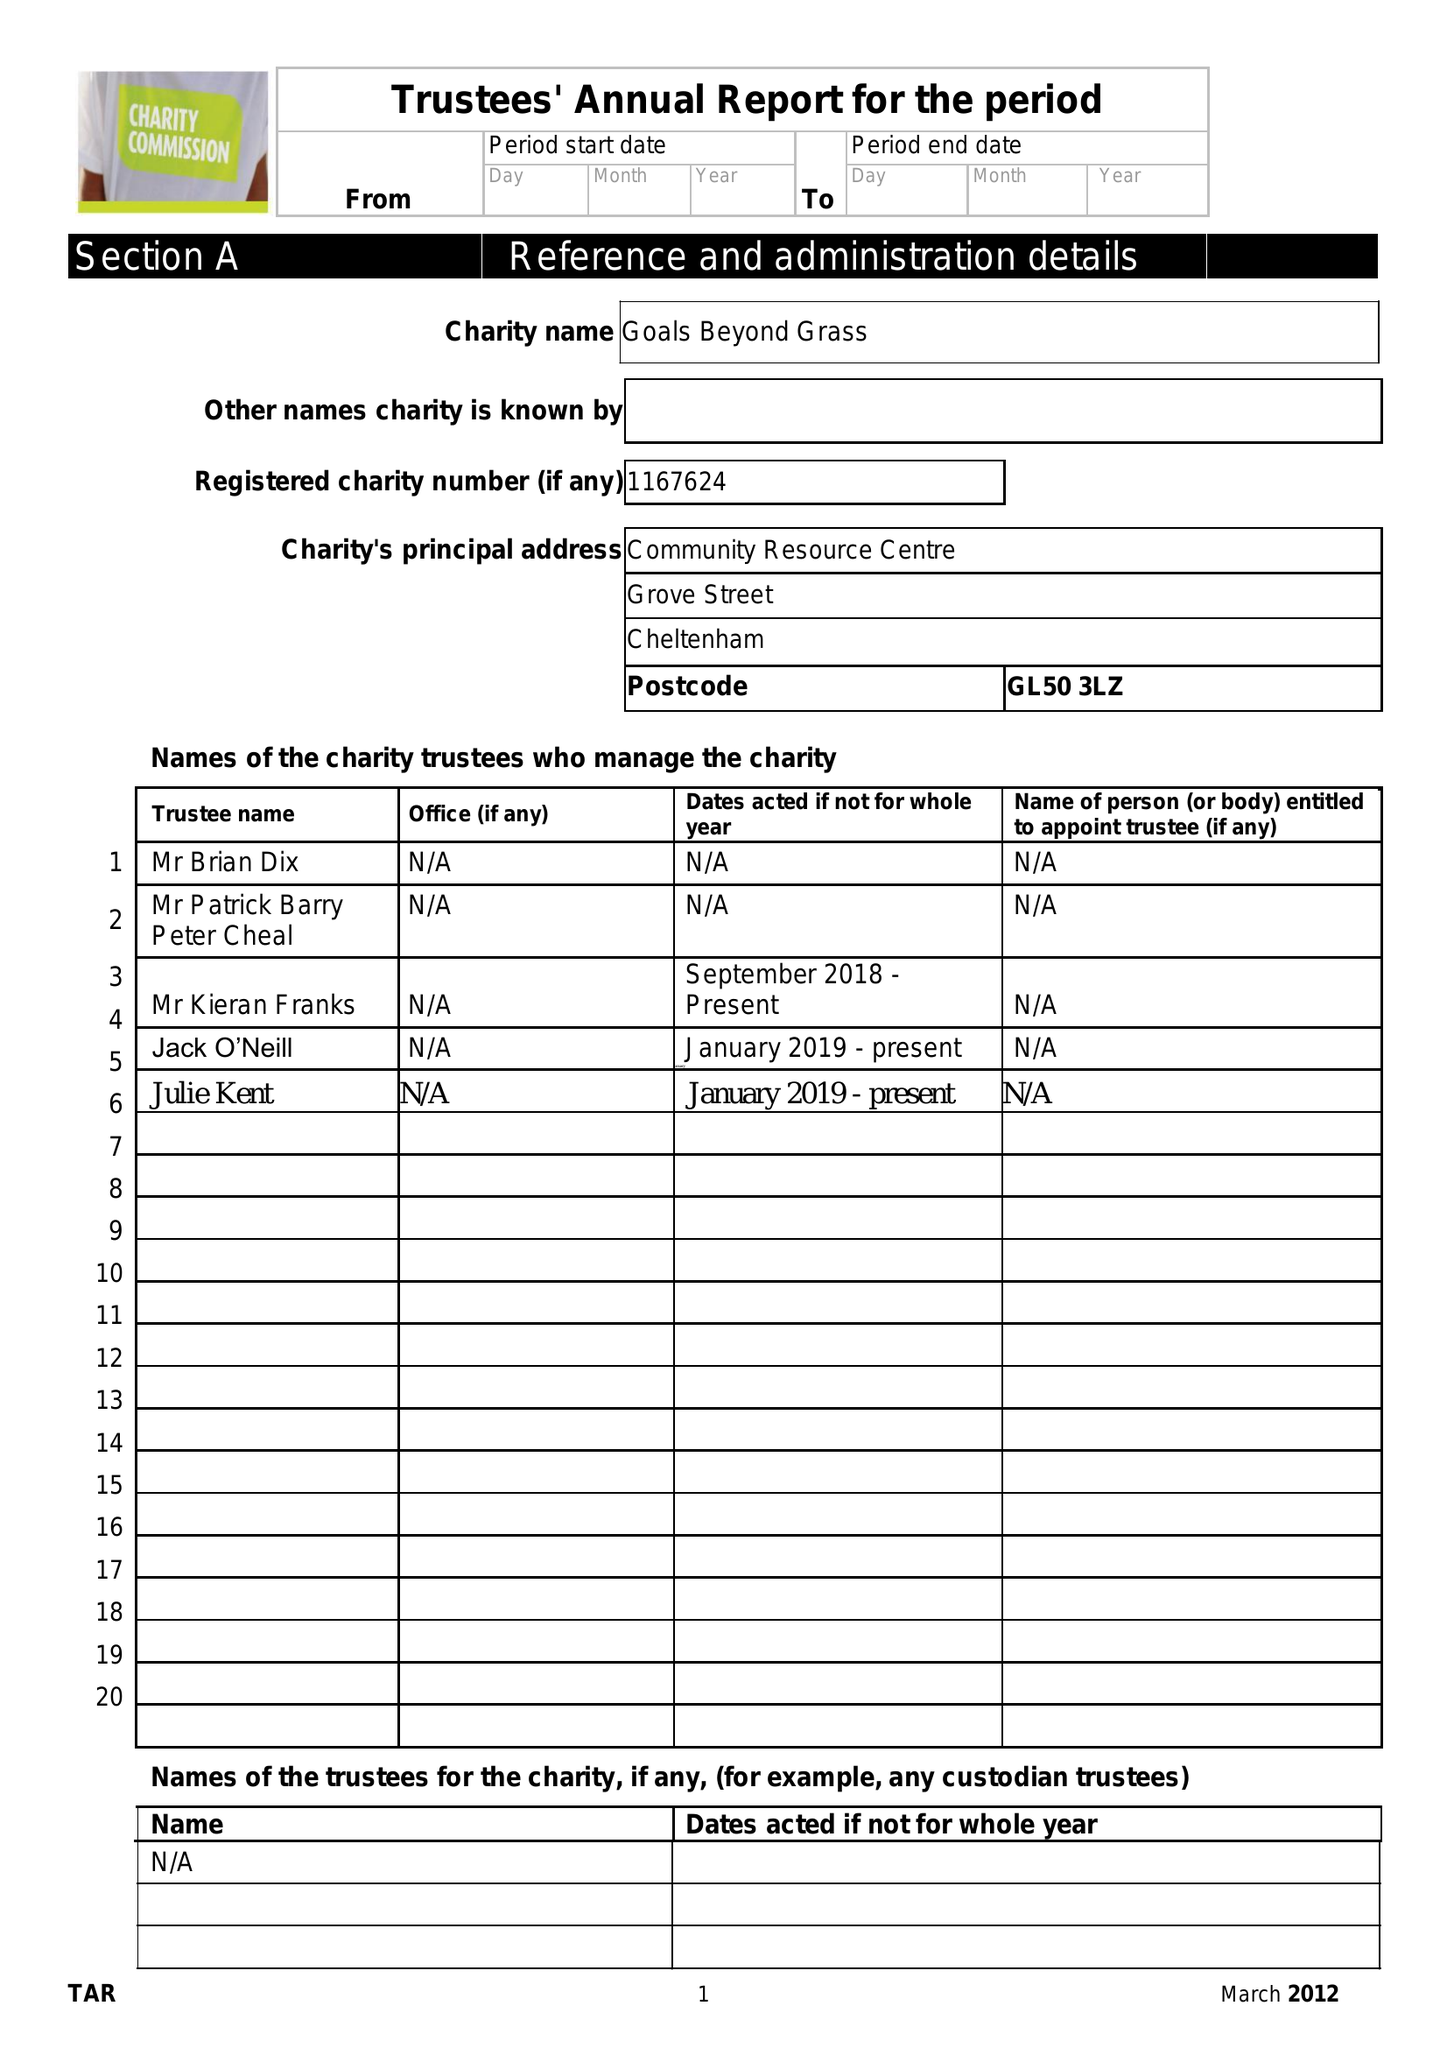What is the value for the report_date?
Answer the question using a single word or phrase. 2018-04-05 